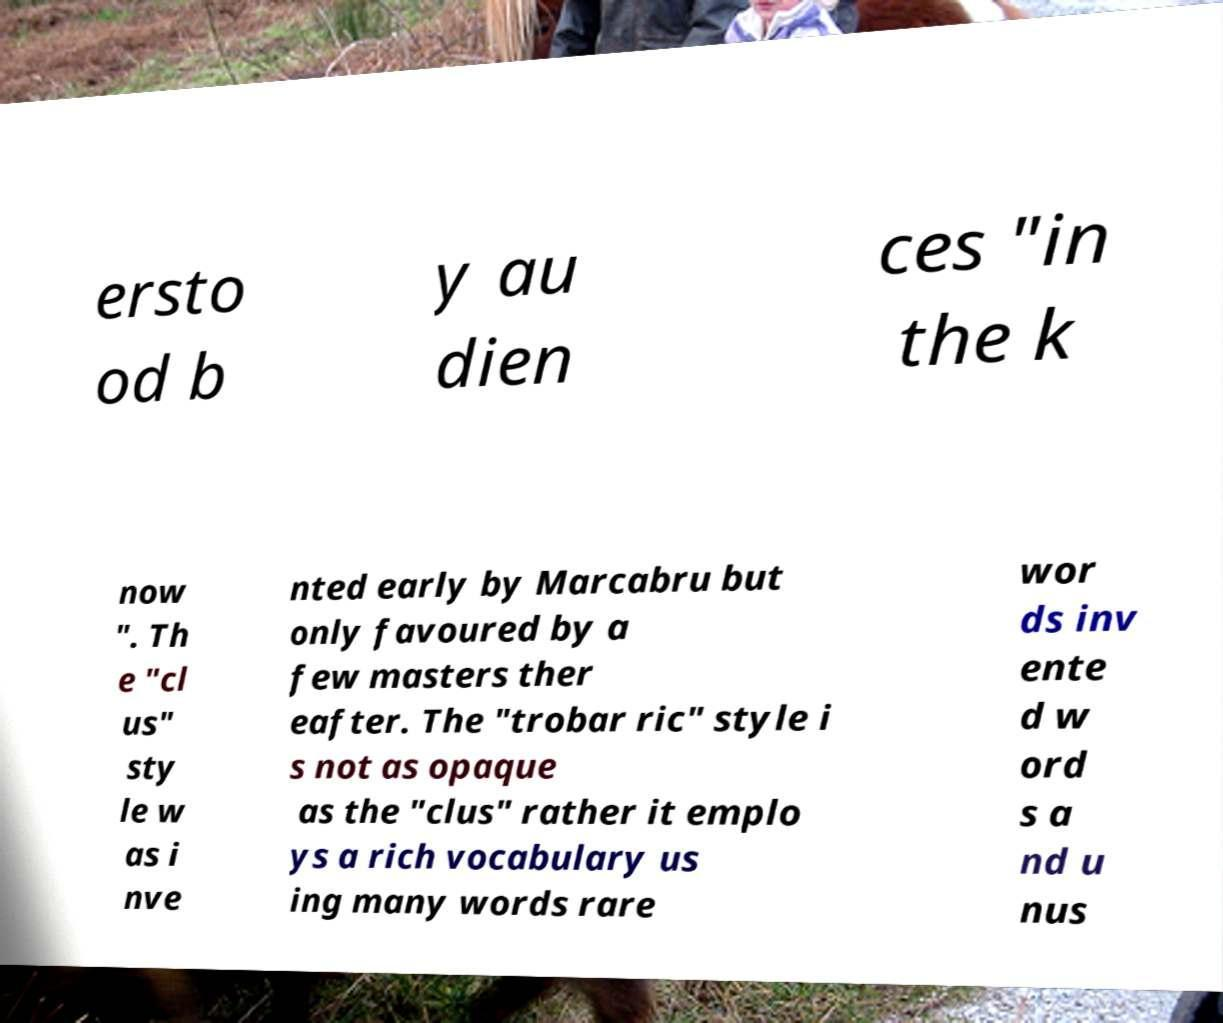What messages or text are displayed in this image? I need them in a readable, typed format. ersto od b y au dien ces "in the k now ". Th e "cl us" sty le w as i nve nted early by Marcabru but only favoured by a few masters ther eafter. The "trobar ric" style i s not as opaque as the "clus" rather it emplo ys a rich vocabulary us ing many words rare wor ds inv ente d w ord s a nd u nus 